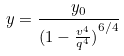<formula> <loc_0><loc_0><loc_500><loc_500>y = \frac { y _ { 0 } } { ( { 1 - \frac { v ^ { 4 } } { q ^ { 4 } } ) } ^ { 6 / 4 } }</formula> 